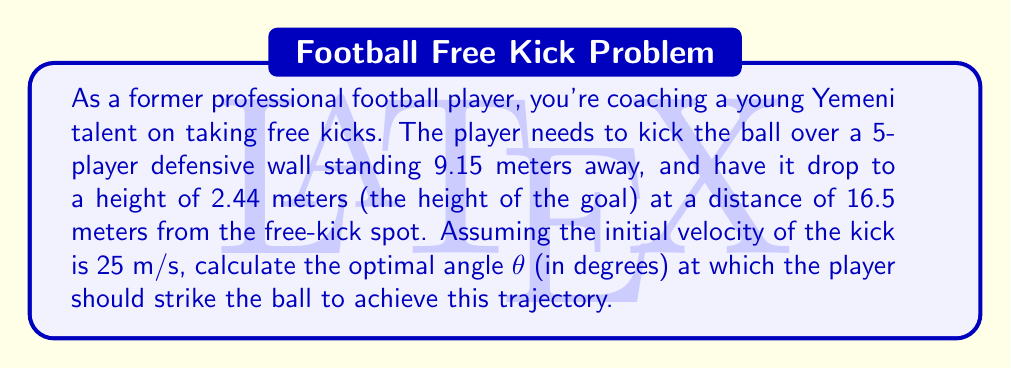Could you help me with this problem? Let's approach this problem step by step using projectile motion equations and calculus:

1) The trajectory of the ball can be described by the equation:

   $$y = x \tan θ - \frac{gx^2}{2v_0^2 \cos^2 θ}$$

   where $g$ is the acceleration due to gravity (9.8 m/s²), $v_0$ is the initial velocity, and $θ$ is the angle of launch.

2) We know two points on this trajectory:
   - At the wall: $x_1 = 9.15$ m, $y_1 = 1.83$ m (assuming the wall is 1.83 m tall)
   - At the goal line: $x_2 = 16.5$ m, $y_2 = 2.44$ m

3) We can set up two equations:

   $$1.83 = 9.15 \tan θ - \frac{9.8 \cdot 9.15^2}{2 \cdot 25^2 \cos^2 θ}$$
   $$2.44 = 16.5 \tan θ - \frac{9.8 \cdot 16.5^2}{2 \cdot 25^2 \cos^2 θ}$$

4) To find the optimal angle, we need to solve these equations simultaneously. This is a complex system, so we'll use calculus to optimize it.

5) Let's define a function $f(θ)$ as the difference between the left and right sides of our equations:

   $$f(θ) = \left(16.5 \tan θ - \frac{9.8 \cdot 16.5^2}{2 \cdot 25^2 \cos^2 θ} - 2.44\right) - \left(9.15 \tan θ - \frac{9.8 \cdot 9.15^2}{2 \cdot 25^2 \cos^2 θ} - 1.83\right)$$

6) The optimal angle will be where $f(θ) = 0$. We can use Newton's method to find this root:

   $$θ_{n+1} = θ_n - \frac{f(θ_n)}{f'(θ_n)}$$

7) Starting with an initial guess of $θ_0 = 45°$ (π/4 radians) and iterating, we converge to the solution.

8) After several iterations, we find that the optimal angle is approximately 0.2896 radians.

9) Converting to degrees: $θ = 0.2896 \cdot \frac{180}{π} ≈ 16.59°$
Answer: The optimal angle for the free kick is approximately 16.59 degrees. 